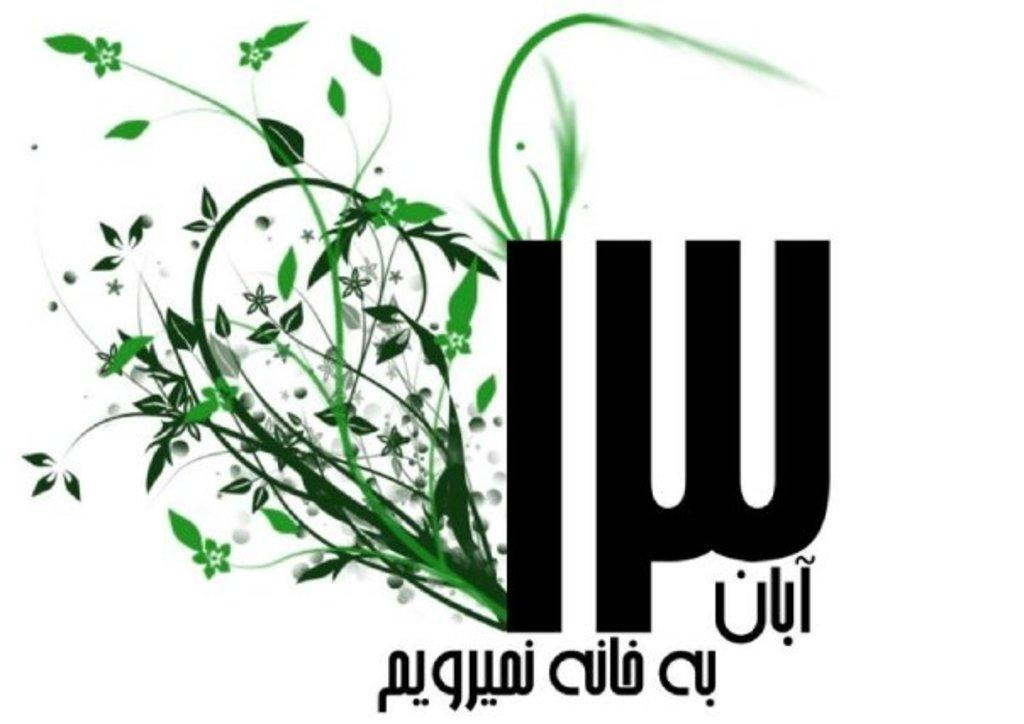What type of artwork is depicted in the image? The image is a digital painting. What can be seen on the left side of the image? There are stems with leaves on the left side of the image. What is present on the right side of the image? There is text on the right side of the image. What color is the background of the image? The background of the image is white. How does the ghost interact with the stems and leaves in the image? There is no ghost present in the image; it only features stems with leaves, text, and a white background. 